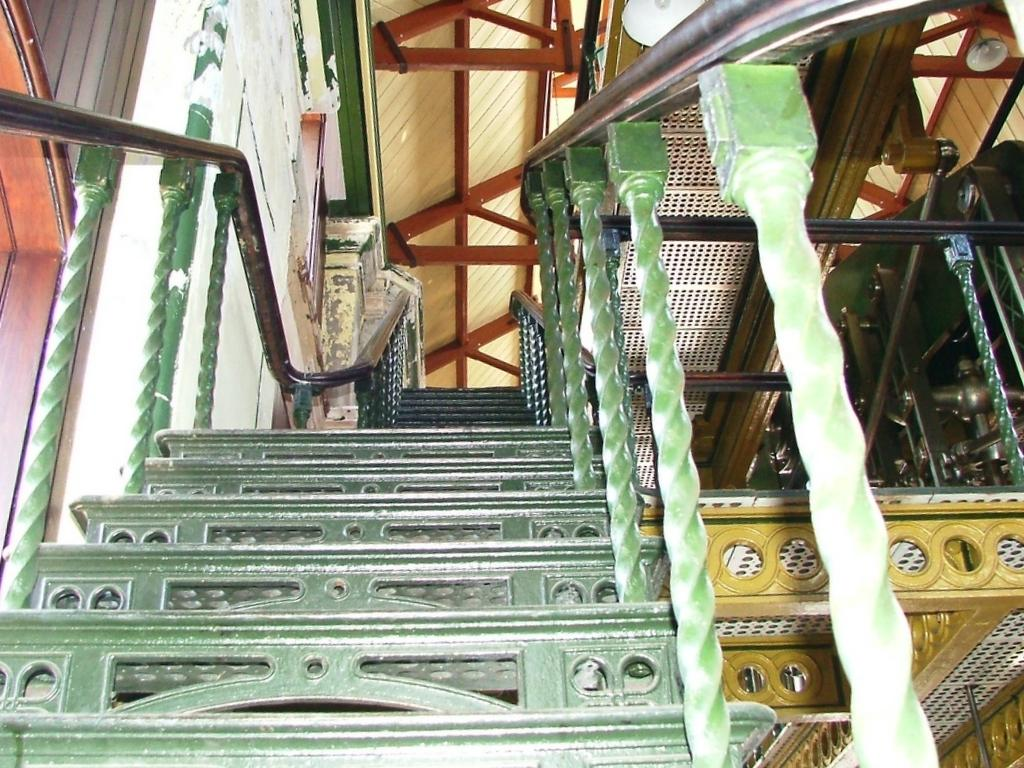What type of architectural feature is present in the image? There are stairs in the image. What part of the building can be seen at the top of the image? The ceiling is visible at the top of the image. What safety feature is present in the image? There is a railing in the image. What type of structure is on the left side of the image? There is a wall on the left side of the image. How many ants can be seen crawling on the wall in the image? There are no ants present in the image; it only features stairs, a railing, a wall, and a ceiling. What type of police equipment is visible in the image? There is no police equipment present in the image. 